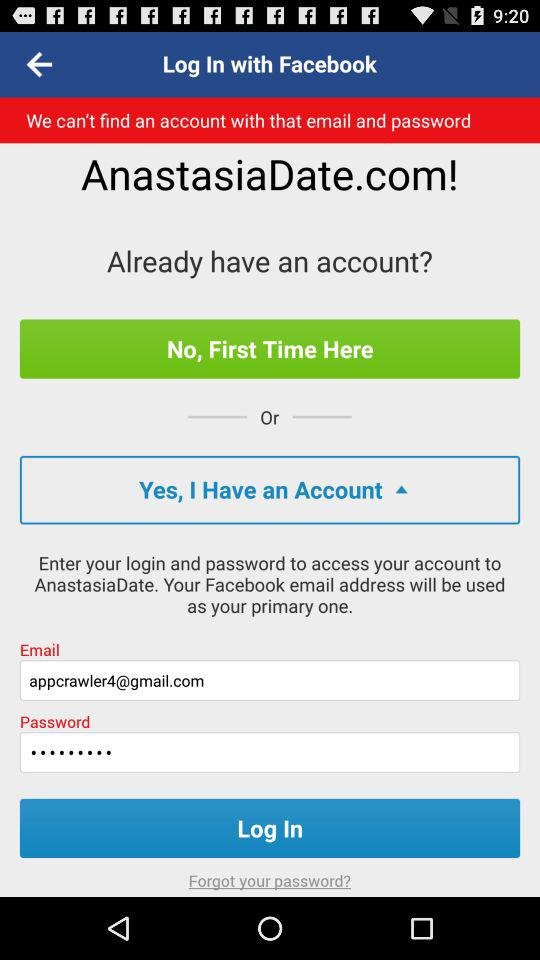Through what application can we log in? You can log in through "Facebook". 